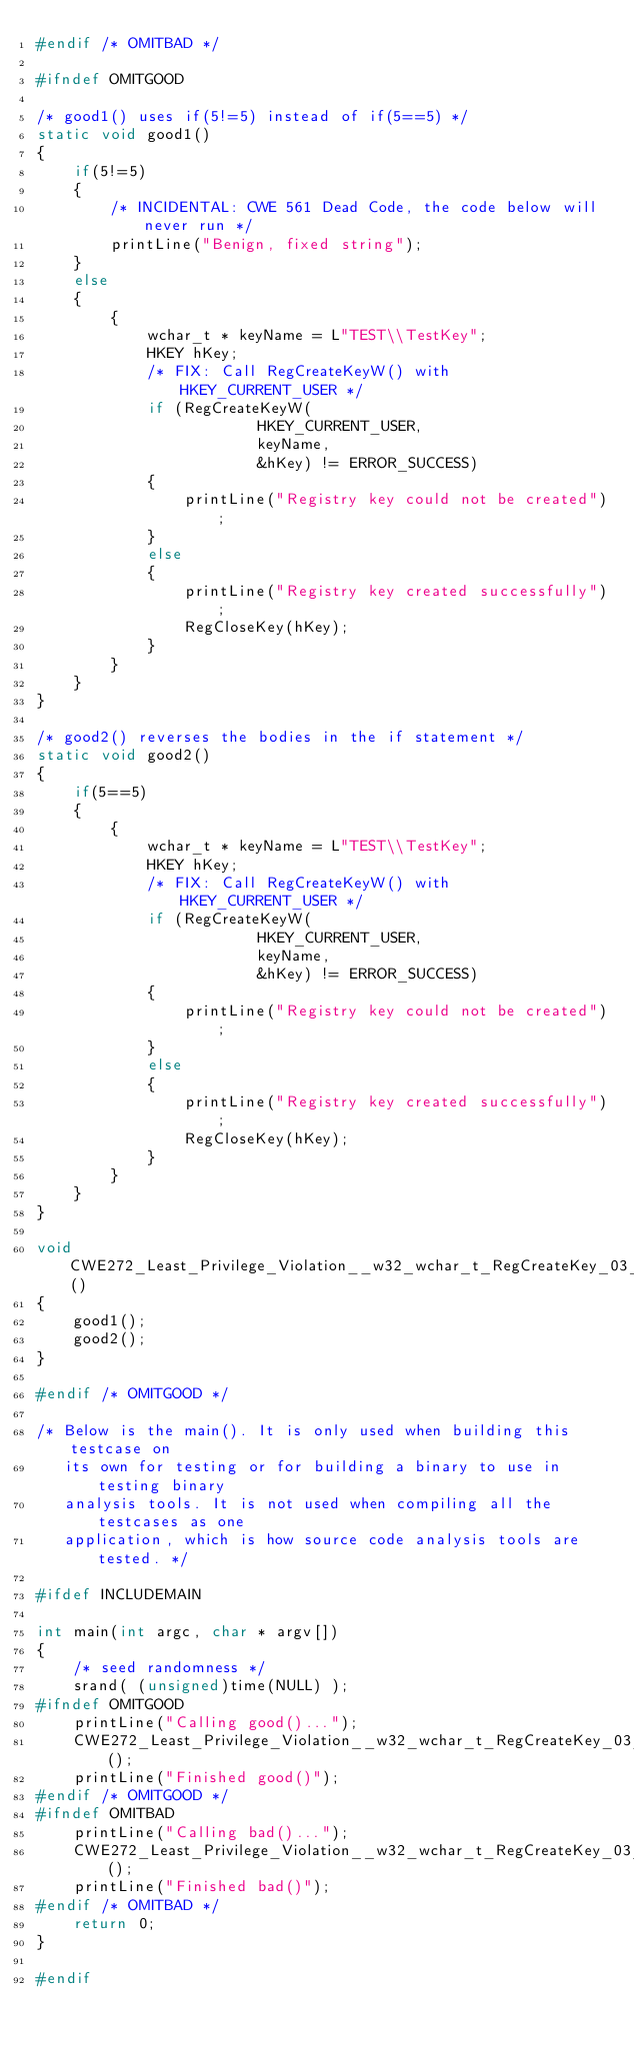Convert code to text. <code><loc_0><loc_0><loc_500><loc_500><_C_>#endif /* OMITBAD */

#ifndef OMITGOOD

/* good1() uses if(5!=5) instead of if(5==5) */
static void good1()
{
    if(5!=5)
    {
        /* INCIDENTAL: CWE 561 Dead Code, the code below will never run */
        printLine("Benign, fixed string");
    }
    else
    {
        {
            wchar_t * keyName = L"TEST\\TestKey";
            HKEY hKey;
            /* FIX: Call RegCreateKeyW() with HKEY_CURRENT_USER */
            if (RegCreateKeyW(
                        HKEY_CURRENT_USER,
                        keyName,
                        &hKey) != ERROR_SUCCESS)
            {
                printLine("Registry key could not be created");
            }
            else
            {
                printLine("Registry key created successfully");
                RegCloseKey(hKey);
            }
        }
    }
}

/* good2() reverses the bodies in the if statement */
static void good2()
{
    if(5==5)
    {
        {
            wchar_t * keyName = L"TEST\\TestKey";
            HKEY hKey;
            /* FIX: Call RegCreateKeyW() with HKEY_CURRENT_USER */
            if (RegCreateKeyW(
                        HKEY_CURRENT_USER,
                        keyName,
                        &hKey) != ERROR_SUCCESS)
            {
                printLine("Registry key could not be created");
            }
            else
            {
                printLine("Registry key created successfully");
                RegCloseKey(hKey);
            }
        }
    }
}

void CWE272_Least_Privilege_Violation__w32_wchar_t_RegCreateKey_03_good()
{
    good1();
    good2();
}

#endif /* OMITGOOD */

/* Below is the main(). It is only used when building this testcase on
   its own for testing or for building a binary to use in testing binary
   analysis tools. It is not used when compiling all the testcases as one
   application, which is how source code analysis tools are tested. */

#ifdef INCLUDEMAIN

int main(int argc, char * argv[])
{
    /* seed randomness */
    srand( (unsigned)time(NULL) );
#ifndef OMITGOOD
    printLine("Calling good()...");
    CWE272_Least_Privilege_Violation__w32_wchar_t_RegCreateKey_03_good();
    printLine("Finished good()");
#endif /* OMITGOOD */
#ifndef OMITBAD
    printLine("Calling bad()...");
    CWE272_Least_Privilege_Violation__w32_wchar_t_RegCreateKey_03_bad();
    printLine("Finished bad()");
#endif /* OMITBAD */
    return 0;
}

#endif
</code> 